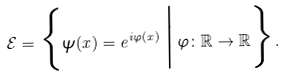<formula> <loc_0><loc_0><loc_500><loc_500>\mathcal { E } = \Big \{ \psi ( x ) = e ^ { i \varphi ( x ) } \, \Big | \, \varphi \colon \mathbb { R } \to \mathbb { R } \Big \} .</formula> 